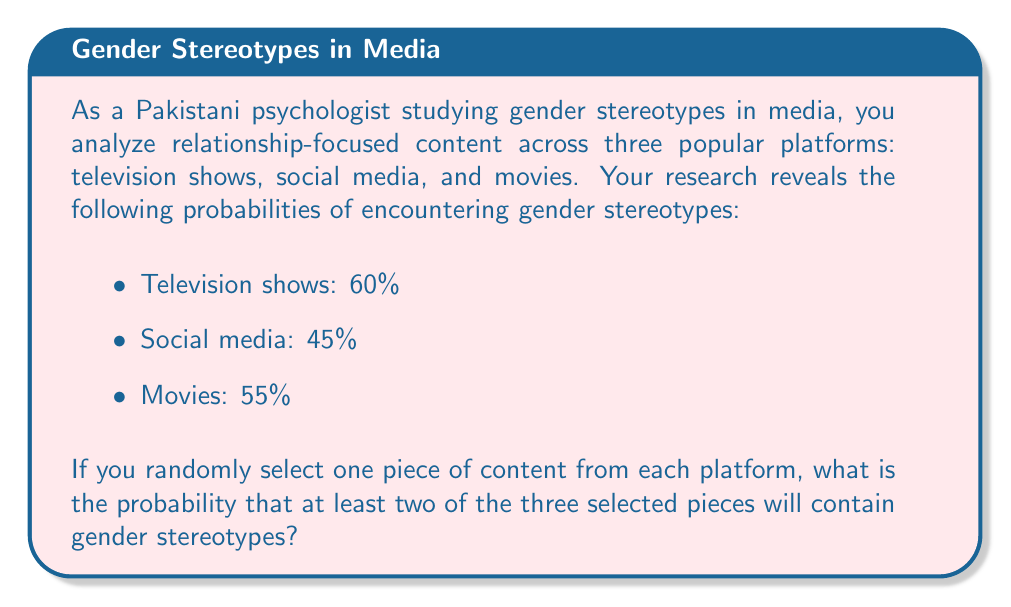Can you solve this math problem? To solve this problem, we can use the complement method:

1) First, let's calculate the probability of the complement event: 0 or 1 piece of content containing stereotypes.

2) Probability of no stereotypes in any content:
   $P(\text{none}) = (1-0.60) \times (1-0.45) \times (1-0.55) = 0.4 \times 0.55 \times 0.45 = 0.099$

3) Probability of exactly one piece containing stereotypes:
   $P(\text{TV only}) = 0.60 \times 0.55 \times 0.45 = 0.1485$
   $P(\text{Social media only}) = 0.40 \times 0.45 \times 0.45 = 0.0810$
   $P(\text{Movies only}) = 0.40 \times 0.55 \times 0.55 = 0.1210$

   $P(\text{exactly one}) = 0.1485 + 0.0810 + 0.1210 = 0.3505$

4) Probability of 0 or 1 piece containing stereotypes:
   $P(0 \text{ or } 1) = 0.099 + 0.3505 = 0.4495$

5) Therefore, the probability of at least two pieces containing stereotypes is:
   $P(\text{at least two}) = 1 - P(0 \text{ or } 1) = 1 - 0.4495 = 0.5505$
Answer: The probability that at least two of the three randomly selected pieces of content will contain gender stereotypes is 0.5505 or approximately 55.05%. 